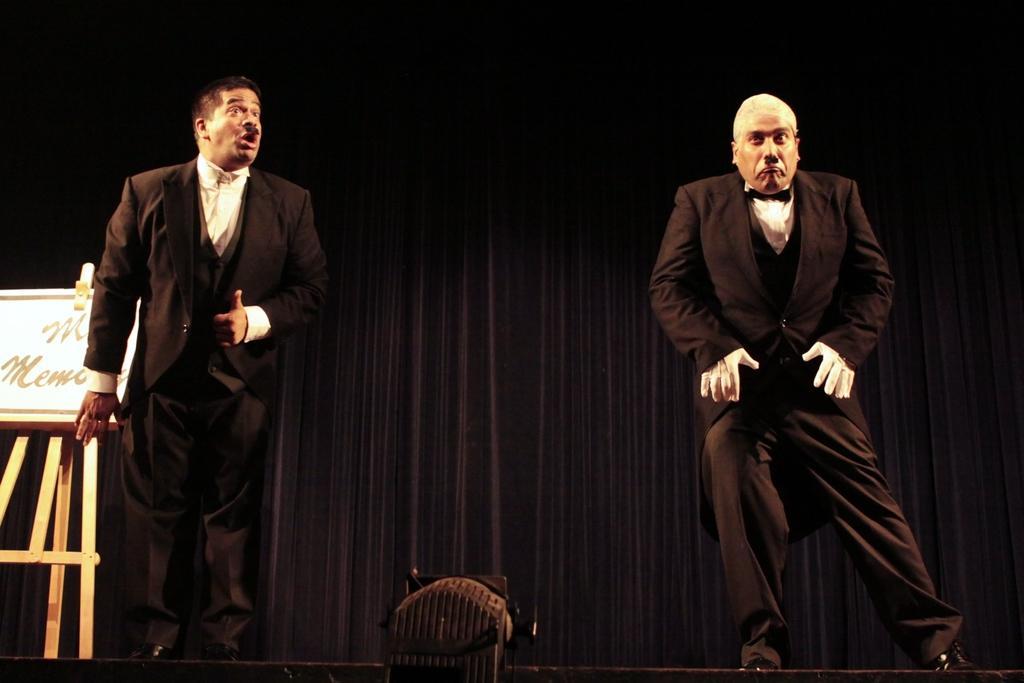Please provide a concise description of this image. There are two performers on the stage performing. In the background there is a black colour curtain. At the right side there is a board and wooden stand. In the front there is a light. 